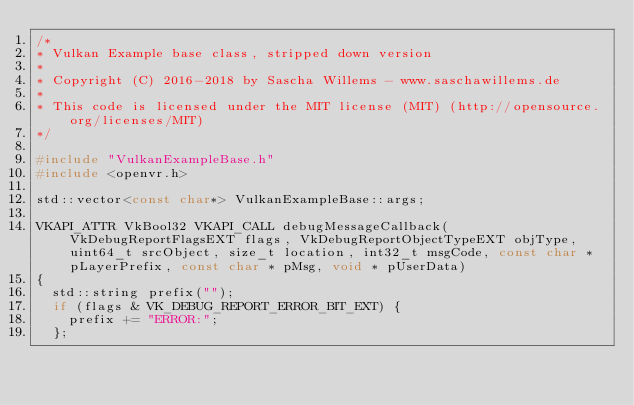Convert code to text. <code><loc_0><loc_0><loc_500><loc_500><_C++_>/*
* Vulkan Example base class, stripped down version
*
* Copyright (C) 2016-2018 by Sascha Willems - www.saschawillems.de
*
* This code is licensed under the MIT license (MIT) (http://opensource.org/licenses/MIT)
*/

#include "VulkanExampleBase.h"
#include <openvr.h>

std::vector<const char*> VulkanExampleBase::args;

VKAPI_ATTR VkBool32 VKAPI_CALL debugMessageCallback(VkDebugReportFlagsEXT flags, VkDebugReportObjectTypeEXT objType, uint64_t srcObject, size_t location, int32_t msgCode, const char * pLayerPrefix, const char * pMsg, void * pUserData)
{
	std::string prefix("");
	if (flags & VK_DEBUG_REPORT_ERROR_BIT_EXT) {
		prefix += "ERROR:";
	};</code> 